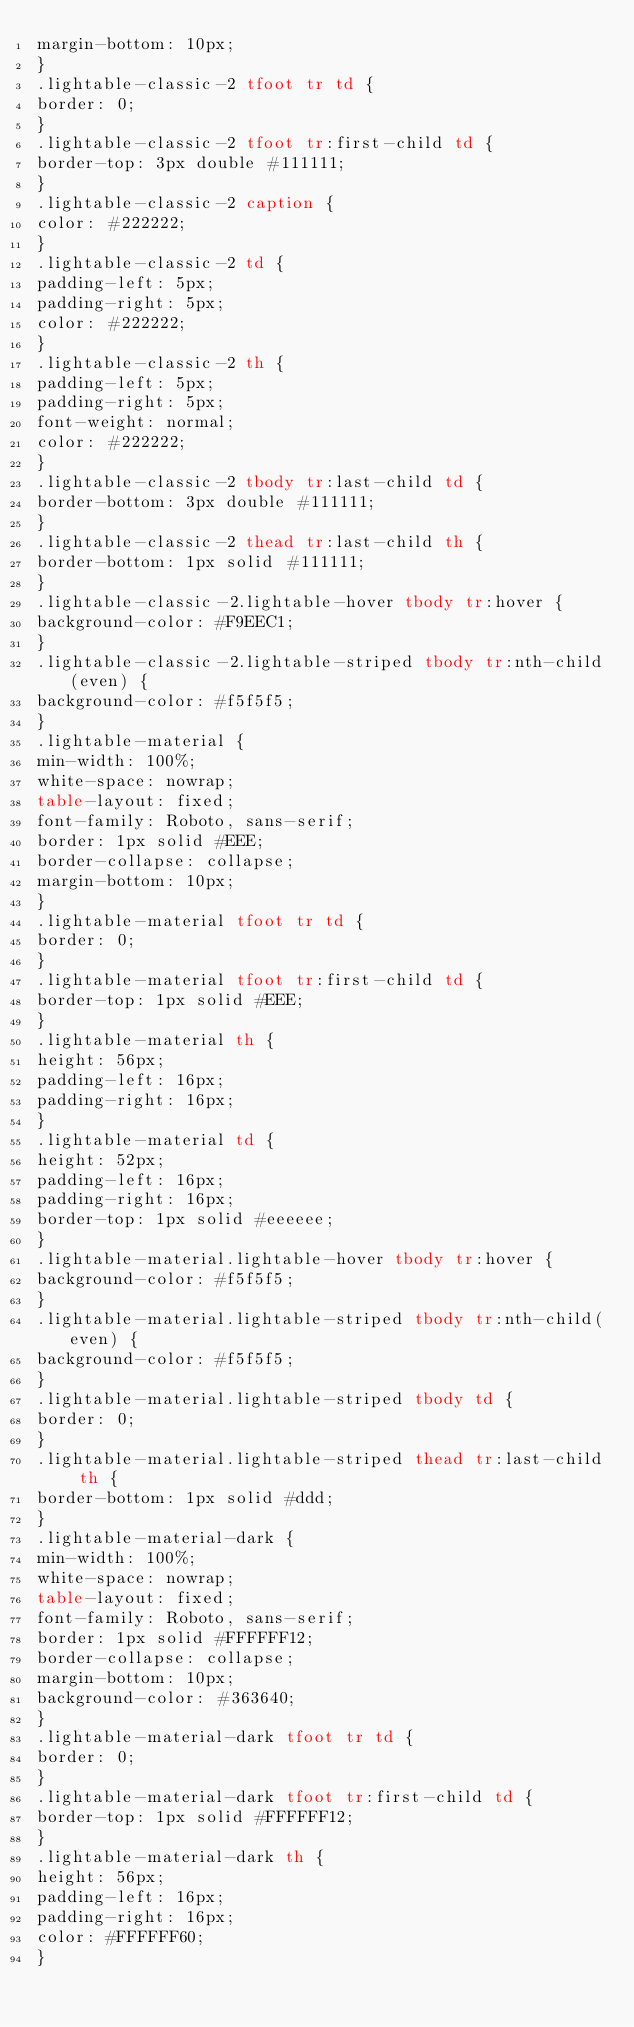Convert code to text. <code><loc_0><loc_0><loc_500><loc_500><_HTML_>margin-bottom: 10px;
}
.lightable-classic-2 tfoot tr td {
border: 0;
}
.lightable-classic-2 tfoot tr:first-child td {
border-top: 3px double #111111;
}
.lightable-classic-2 caption {
color: #222222;
}
.lightable-classic-2 td {
padding-left: 5px;
padding-right: 5px;
color: #222222;
}
.lightable-classic-2 th {
padding-left: 5px;
padding-right: 5px;
font-weight: normal;
color: #222222;
}
.lightable-classic-2 tbody tr:last-child td {
border-bottom: 3px double #111111;
}
.lightable-classic-2 thead tr:last-child th {
border-bottom: 1px solid #111111;
}
.lightable-classic-2.lightable-hover tbody tr:hover {
background-color: #F9EEC1;
}
.lightable-classic-2.lightable-striped tbody tr:nth-child(even) {
background-color: #f5f5f5;
}
.lightable-material {
min-width: 100%;
white-space: nowrap;
table-layout: fixed;
font-family: Roboto, sans-serif;
border: 1px solid #EEE;
border-collapse: collapse;
margin-bottom: 10px;
}
.lightable-material tfoot tr td {
border: 0;
}
.lightable-material tfoot tr:first-child td {
border-top: 1px solid #EEE;
}
.lightable-material th {
height: 56px;
padding-left: 16px;
padding-right: 16px;
}
.lightable-material td {
height: 52px;
padding-left: 16px;
padding-right: 16px;
border-top: 1px solid #eeeeee;
}
.lightable-material.lightable-hover tbody tr:hover {
background-color: #f5f5f5;
}
.lightable-material.lightable-striped tbody tr:nth-child(even) {
background-color: #f5f5f5;
}
.lightable-material.lightable-striped tbody td {
border: 0;
}
.lightable-material.lightable-striped thead tr:last-child th {
border-bottom: 1px solid #ddd;
}
.lightable-material-dark {
min-width: 100%;
white-space: nowrap;
table-layout: fixed;
font-family: Roboto, sans-serif;
border: 1px solid #FFFFFF12;
border-collapse: collapse;
margin-bottom: 10px;
background-color: #363640;
}
.lightable-material-dark tfoot tr td {
border: 0;
}
.lightable-material-dark tfoot tr:first-child td {
border-top: 1px solid #FFFFFF12;
}
.lightable-material-dark th {
height: 56px;
padding-left: 16px;
padding-right: 16px;
color: #FFFFFF60;
}</code> 